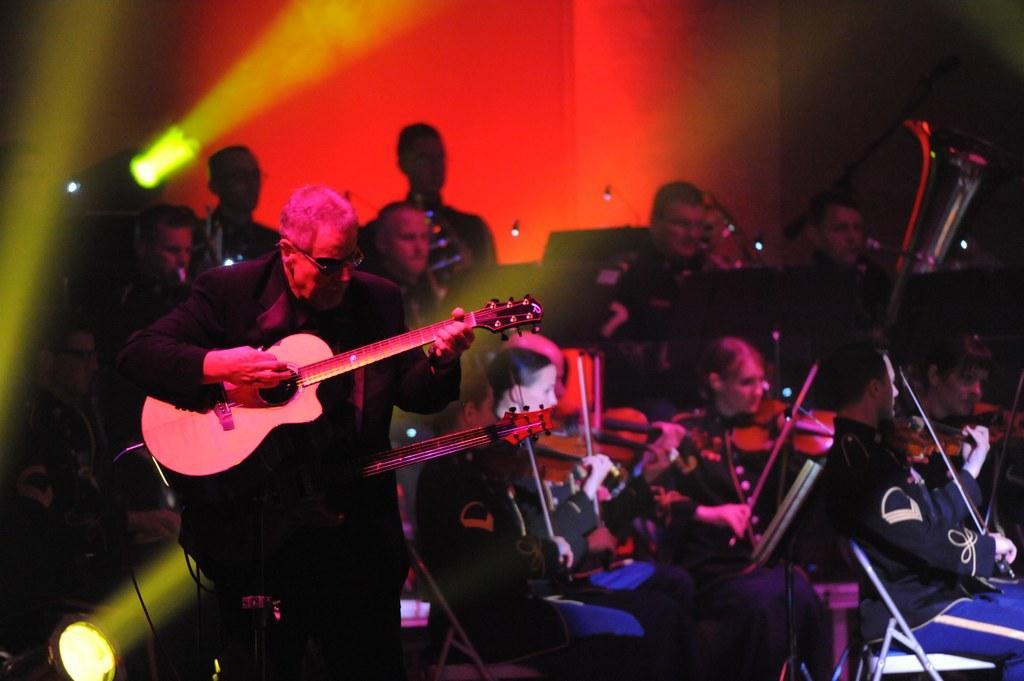Could you give a brief overview of what you see in this image? There are group of people playing musical instruments on stage. 